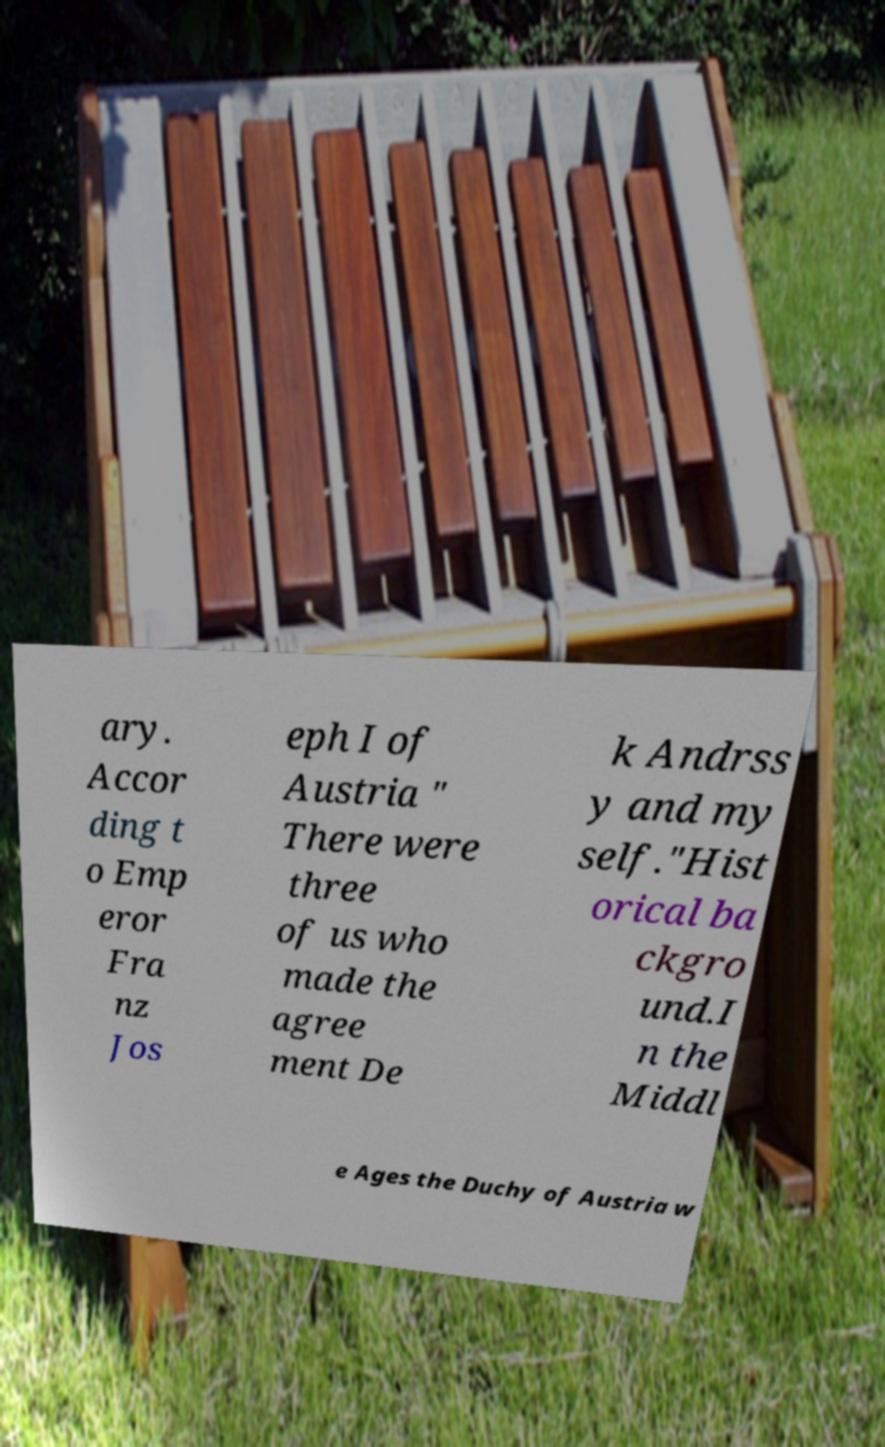Could you assist in decoding the text presented in this image and type it out clearly? ary. Accor ding t o Emp eror Fra nz Jos eph I of Austria " There were three of us who made the agree ment De k Andrss y and my self."Hist orical ba ckgro und.I n the Middl e Ages the Duchy of Austria w 